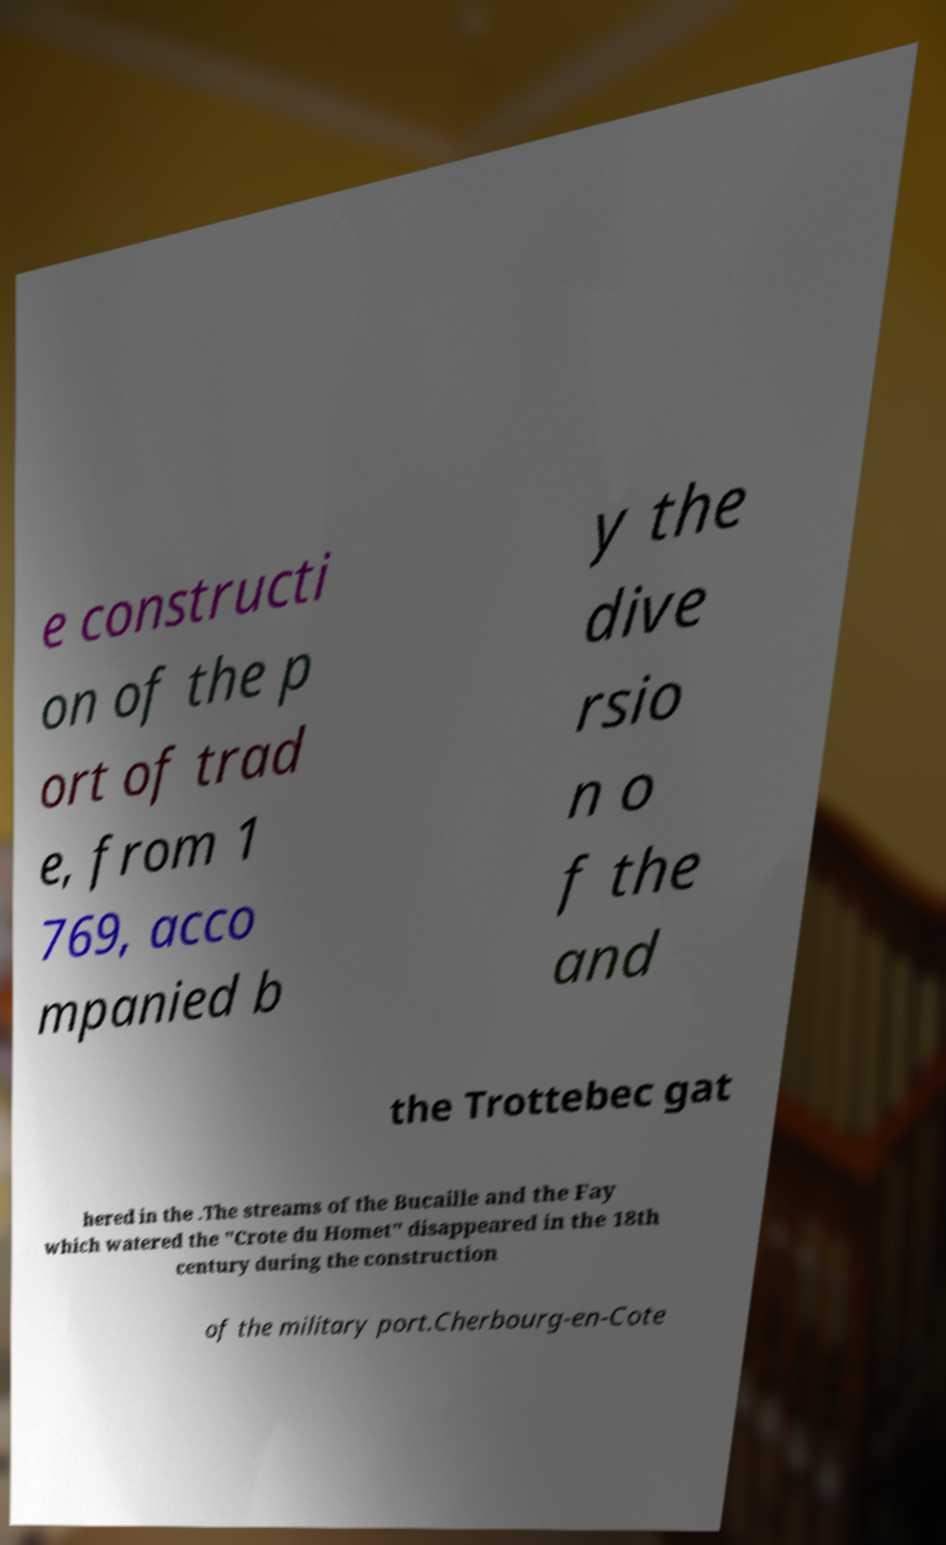Could you extract and type out the text from this image? e constructi on of the p ort of trad e, from 1 769, acco mpanied b y the dive rsio n o f the and the Trottebec gat hered in the .The streams of the Bucaille and the Fay which watered the "Crote du Homet" disappeared in the 18th century during the construction of the military port.Cherbourg-en-Cote 